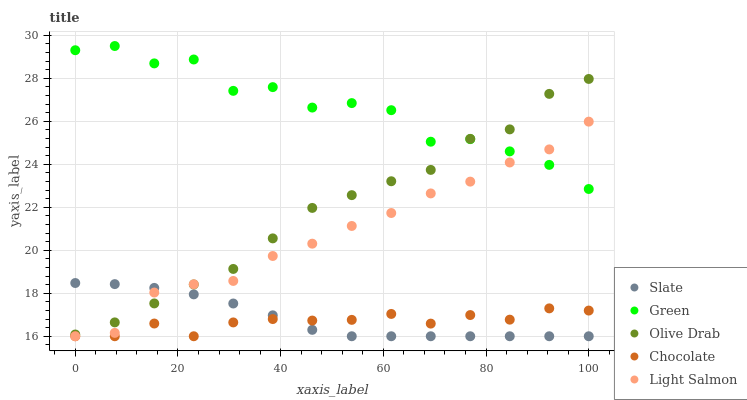Does Chocolate have the minimum area under the curve?
Answer yes or no. Yes. Does Green have the maximum area under the curve?
Answer yes or no. Yes. Does Light Salmon have the minimum area under the curve?
Answer yes or no. No. Does Light Salmon have the maximum area under the curve?
Answer yes or no. No. Is Slate the smoothest?
Answer yes or no. Yes. Is Green the roughest?
Answer yes or no. Yes. Is Light Salmon the smoothest?
Answer yes or no. No. Is Light Salmon the roughest?
Answer yes or no. No. Does Slate have the lowest value?
Answer yes or no. Yes. Does Green have the lowest value?
Answer yes or no. No. Does Green have the highest value?
Answer yes or no. Yes. Does Light Salmon have the highest value?
Answer yes or no. No. Is Chocolate less than Green?
Answer yes or no. Yes. Is Green greater than Chocolate?
Answer yes or no. Yes. Does Slate intersect Chocolate?
Answer yes or no. Yes. Is Slate less than Chocolate?
Answer yes or no. No. Is Slate greater than Chocolate?
Answer yes or no. No. Does Chocolate intersect Green?
Answer yes or no. No. 